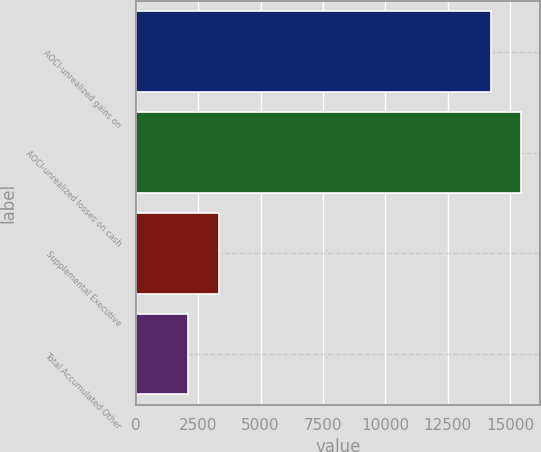Convert chart. <chart><loc_0><loc_0><loc_500><loc_500><bar_chart><fcel>AOCI-unrealized gains on<fcel>AOCI-unrealized losses on cash<fcel>Supplemental Executive<fcel>Total Accumulated Other<nl><fcel>14222<fcel>15436.1<fcel>3316.1<fcel>2102<nl></chart> 